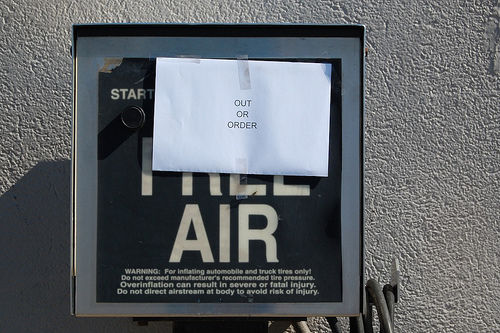<image>
Is the mailbox to the left of the hose? Yes. From this viewpoint, the mailbox is positioned to the left side relative to the hose. 